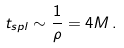<formula> <loc_0><loc_0><loc_500><loc_500>t _ { s p l } \sim \frac { 1 } { \rho } = 4 M \, .</formula> 